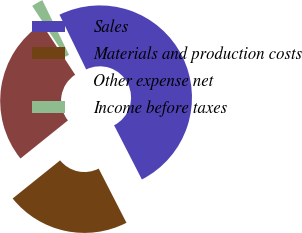Convert chart. <chart><loc_0><loc_0><loc_500><loc_500><pie_chart><fcel>Sales<fcel>Materials and production costs<fcel>Other expense net<fcel>Income before taxes<nl><fcel>49.68%<fcel>21.77%<fcel>26.53%<fcel>2.02%<nl></chart> 